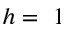<formula> <loc_0><loc_0><loc_500><loc_500>h = 1</formula> 